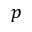Convert formula to latex. <formula><loc_0><loc_0><loc_500><loc_500>p</formula> 